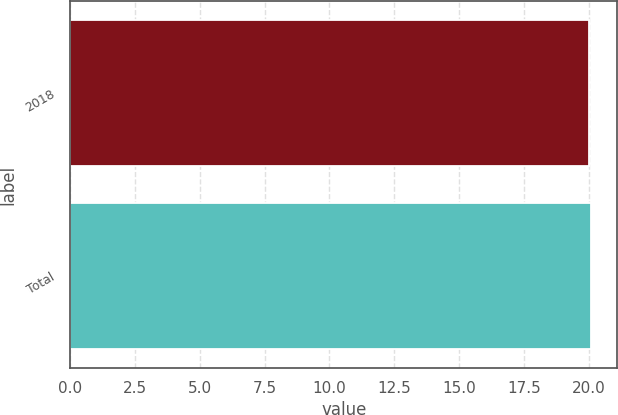<chart> <loc_0><loc_0><loc_500><loc_500><bar_chart><fcel>2018<fcel>Total<nl><fcel>20<fcel>20.1<nl></chart> 